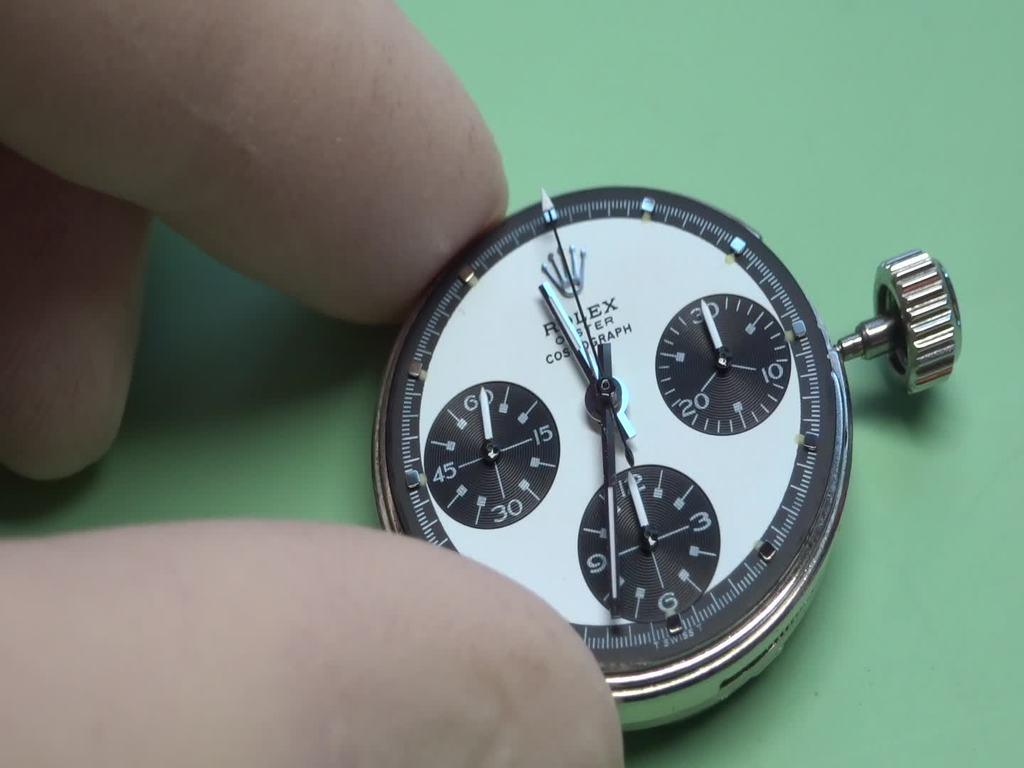<image>
Relay a brief, clear account of the picture shown. Person holding a face of a watch which says ROLEX on it. 